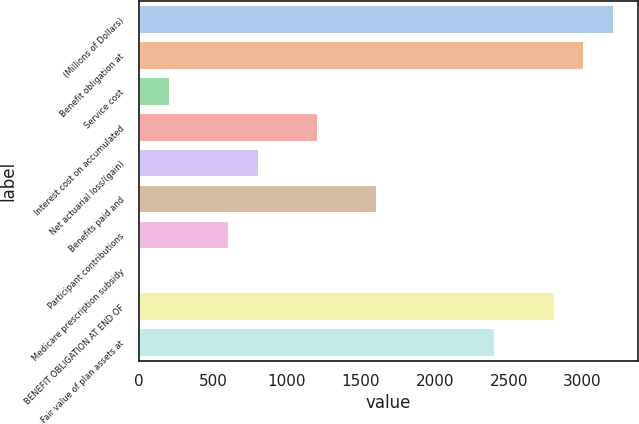Convert chart. <chart><loc_0><loc_0><loc_500><loc_500><bar_chart><fcel>(Millions of Dollars)<fcel>Benefit obligation at<fcel>Service cost<fcel>Interest cost on accumulated<fcel>Net actuarial loss/(gain)<fcel>Benefits paid and<fcel>Participant contributions<fcel>Medicare prescription subsidy<fcel>BENEFIT OBLIGATION AT END OF<fcel>Fair value of plan assets at<nl><fcel>3211.8<fcel>3011.5<fcel>207.3<fcel>1208.8<fcel>808.2<fcel>1609.4<fcel>607.9<fcel>7<fcel>2811.2<fcel>2410.6<nl></chart> 